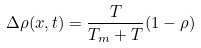Convert formula to latex. <formula><loc_0><loc_0><loc_500><loc_500>\Delta \rho ( x , t ) = \frac { T } { T _ { m } + T } ( 1 - \rho )</formula> 